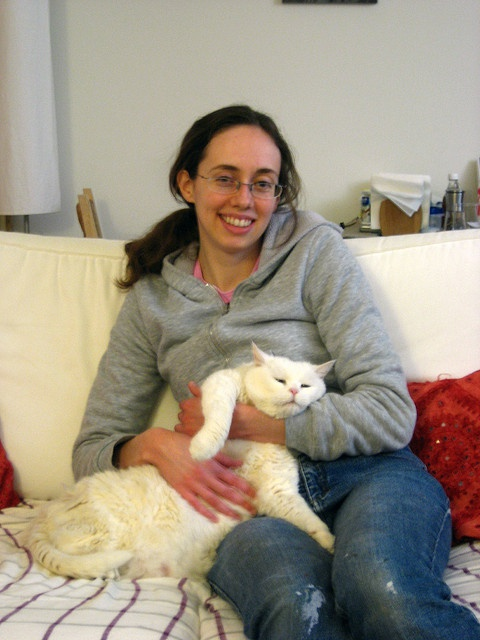Describe the objects in this image and their specific colors. I can see people in gray, black, darkgray, and blue tones, bed in gray, tan, ivory, maroon, and darkgray tones, couch in gray, tan, ivory, maroon, and darkgray tones, cat in gray, tan, and beige tones, and chair in gray, darkgray, maroon, and lightgray tones in this image. 